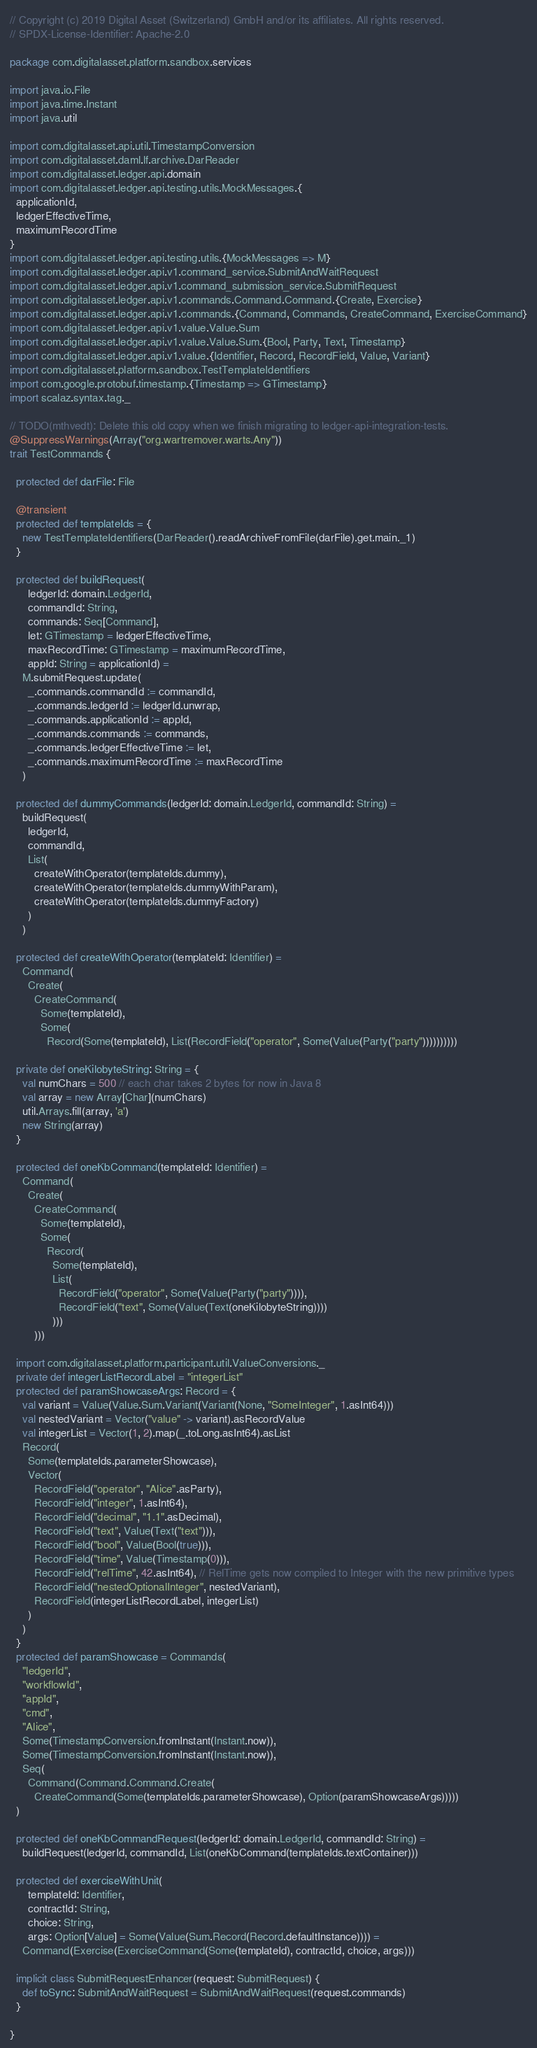Convert code to text. <code><loc_0><loc_0><loc_500><loc_500><_Scala_>// Copyright (c) 2019 Digital Asset (Switzerland) GmbH and/or its affiliates. All rights reserved.
// SPDX-License-Identifier: Apache-2.0

package com.digitalasset.platform.sandbox.services

import java.io.File
import java.time.Instant
import java.util

import com.digitalasset.api.util.TimestampConversion
import com.digitalasset.daml.lf.archive.DarReader
import com.digitalasset.ledger.api.domain
import com.digitalasset.ledger.api.testing.utils.MockMessages.{
  applicationId,
  ledgerEffectiveTime,
  maximumRecordTime
}
import com.digitalasset.ledger.api.testing.utils.{MockMessages => M}
import com.digitalasset.ledger.api.v1.command_service.SubmitAndWaitRequest
import com.digitalasset.ledger.api.v1.command_submission_service.SubmitRequest
import com.digitalasset.ledger.api.v1.commands.Command.Command.{Create, Exercise}
import com.digitalasset.ledger.api.v1.commands.{Command, Commands, CreateCommand, ExerciseCommand}
import com.digitalasset.ledger.api.v1.value.Value.Sum
import com.digitalasset.ledger.api.v1.value.Value.Sum.{Bool, Party, Text, Timestamp}
import com.digitalasset.ledger.api.v1.value.{Identifier, Record, RecordField, Value, Variant}
import com.digitalasset.platform.sandbox.TestTemplateIdentifiers
import com.google.protobuf.timestamp.{Timestamp => GTimestamp}
import scalaz.syntax.tag._

// TODO(mthvedt): Delete this old copy when we finish migrating to ledger-api-integration-tests.
@SuppressWarnings(Array("org.wartremover.warts.Any"))
trait TestCommands {

  protected def darFile: File

  @transient
  protected def templateIds = {
    new TestTemplateIdentifiers(DarReader().readArchiveFromFile(darFile).get.main._1)
  }

  protected def buildRequest(
      ledgerId: domain.LedgerId,
      commandId: String,
      commands: Seq[Command],
      let: GTimestamp = ledgerEffectiveTime,
      maxRecordTime: GTimestamp = maximumRecordTime,
      appId: String = applicationId) =
    M.submitRequest.update(
      _.commands.commandId := commandId,
      _.commands.ledgerId := ledgerId.unwrap,
      _.commands.applicationId := appId,
      _.commands.commands := commands,
      _.commands.ledgerEffectiveTime := let,
      _.commands.maximumRecordTime := maxRecordTime
    )

  protected def dummyCommands(ledgerId: domain.LedgerId, commandId: String) =
    buildRequest(
      ledgerId,
      commandId,
      List(
        createWithOperator(templateIds.dummy),
        createWithOperator(templateIds.dummyWithParam),
        createWithOperator(templateIds.dummyFactory)
      )
    )

  protected def createWithOperator(templateId: Identifier) =
    Command(
      Create(
        CreateCommand(
          Some(templateId),
          Some(
            Record(Some(templateId), List(RecordField("operator", Some(Value(Party("party"))))))))))

  private def oneKilobyteString: String = {
    val numChars = 500 // each char takes 2 bytes for now in Java 8
    val array = new Array[Char](numChars)
    util.Arrays.fill(array, 'a')
    new String(array)
  }

  protected def oneKbCommand(templateId: Identifier) =
    Command(
      Create(
        CreateCommand(
          Some(templateId),
          Some(
            Record(
              Some(templateId),
              List(
                RecordField("operator", Some(Value(Party("party")))),
                RecordField("text", Some(Value(Text(oneKilobyteString))))
              )))
        )))

  import com.digitalasset.platform.participant.util.ValueConversions._
  private def integerListRecordLabel = "integerList"
  protected def paramShowcaseArgs: Record = {
    val variant = Value(Value.Sum.Variant(Variant(None, "SomeInteger", 1.asInt64)))
    val nestedVariant = Vector("value" -> variant).asRecordValue
    val integerList = Vector(1, 2).map(_.toLong.asInt64).asList
    Record(
      Some(templateIds.parameterShowcase),
      Vector(
        RecordField("operator", "Alice".asParty),
        RecordField("integer", 1.asInt64),
        RecordField("decimal", "1.1".asDecimal),
        RecordField("text", Value(Text("text"))),
        RecordField("bool", Value(Bool(true))),
        RecordField("time", Value(Timestamp(0))),
        RecordField("relTime", 42.asInt64), // RelTime gets now compiled to Integer with the new primitive types
        RecordField("nestedOptionalInteger", nestedVariant),
        RecordField(integerListRecordLabel, integerList)
      )
    )
  }
  protected def paramShowcase = Commands(
    "ledgerId",
    "workflowId",
    "appId",
    "cmd",
    "Alice",
    Some(TimestampConversion.fromInstant(Instant.now)),
    Some(TimestampConversion.fromInstant(Instant.now)),
    Seq(
      Command(Command.Command.Create(
        CreateCommand(Some(templateIds.parameterShowcase), Option(paramShowcaseArgs)))))
  )

  protected def oneKbCommandRequest(ledgerId: domain.LedgerId, commandId: String) =
    buildRequest(ledgerId, commandId, List(oneKbCommand(templateIds.textContainer)))

  protected def exerciseWithUnit(
      templateId: Identifier,
      contractId: String,
      choice: String,
      args: Option[Value] = Some(Value(Sum.Record(Record.defaultInstance)))) =
    Command(Exercise(ExerciseCommand(Some(templateId), contractId, choice, args)))

  implicit class SubmitRequestEnhancer(request: SubmitRequest) {
    def toSync: SubmitAndWaitRequest = SubmitAndWaitRequest(request.commands)
  }

}
</code> 